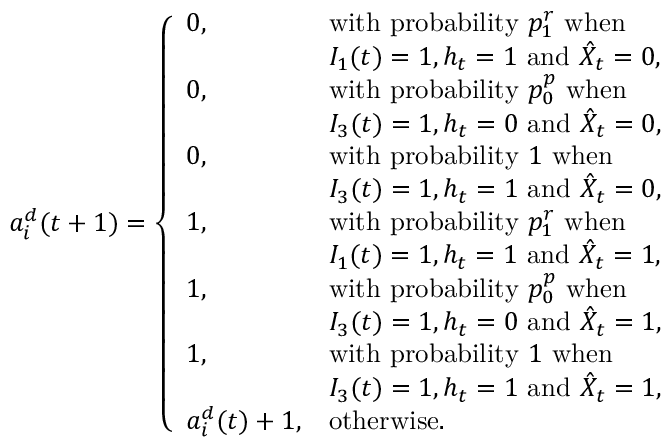<formula> <loc_0><loc_0><loc_500><loc_500>a _ { i } ^ { d } ( t + 1 ) = \left \{ \begin{array} { l l } { 0 , } & { w i t h p r o b a b i l i t y p _ { 1 } ^ { r } w h e n } \\ & { I _ { 1 } ( t ) = 1 , h _ { t } = 1 a n d \hat { X } _ { t } = 0 , } \\ { 0 , } & { w i t h p r o b a b i l i t y p _ { 0 } ^ { p } w h e n } \\ & { I _ { 3 } ( t ) = 1 , h _ { t } = 0 a n d \hat { X } _ { t } = 0 , } \\ { 0 , } & { w i t h p r o b a b i l i t y 1 w h e n } \\ & { I _ { 3 } ( t ) = 1 , h _ { t } = 1 a n d \hat { X } _ { t } = 0 , } \\ { 1 , } & { w i t h p r o b a b i l i t y p _ { 1 } ^ { r } w h e n } \\ & { I _ { 1 } ( t ) = 1 , h _ { t } = 1 a n d \hat { X } _ { t } = 1 , } \\ { 1 , } & { w i t h p r o b a b i l i t y p _ { 0 } ^ { p } w h e n } \\ & { I _ { 3 } ( t ) = 1 , h _ { t } = 0 a n d \hat { X } _ { t } = 1 , } \\ { 1 , } & { w i t h p r o b a b i l i t y 1 w h e n } \\ & { I _ { 3 } ( t ) = 1 , h _ { t } = 1 a n d \hat { X } _ { t } = 1 , } \\ { a _ { i } ^ { d } ( t ) + 1 , } & { o t h e r w i s e . } \end{array}</formula> 